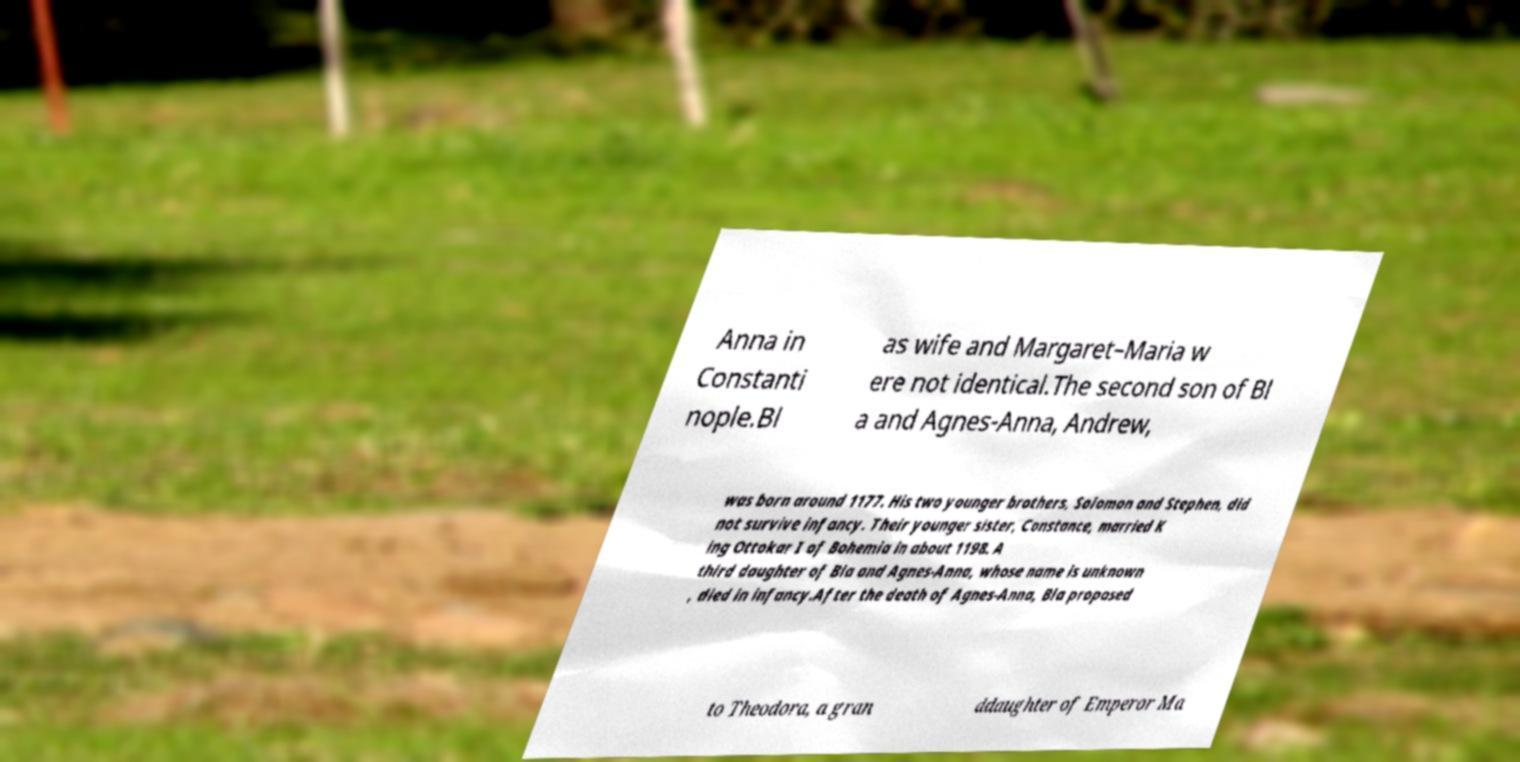Can you read and provide the text displayed in the image?This photo seems to have some interesting text. Can you extract and type it out for me? Anna in Constanti nople.Bl as wife and Margaret–Maria w ere not identical.The second son of Bl a and Agnes-Anna, Andrew, was born around 1177. His two younger brothers, Solomon and Stephen, did not survive infancy. Their younger sister, Constance, married K ing Ottokar I of Bohemia in about 1198. A third daughter of Bla and Agnes-Anna, whose name is unknown , died in infancy.After the death of Agnes-Anna, Bla proposed to Theodora, a gran ddaughter of Emperor Ma 